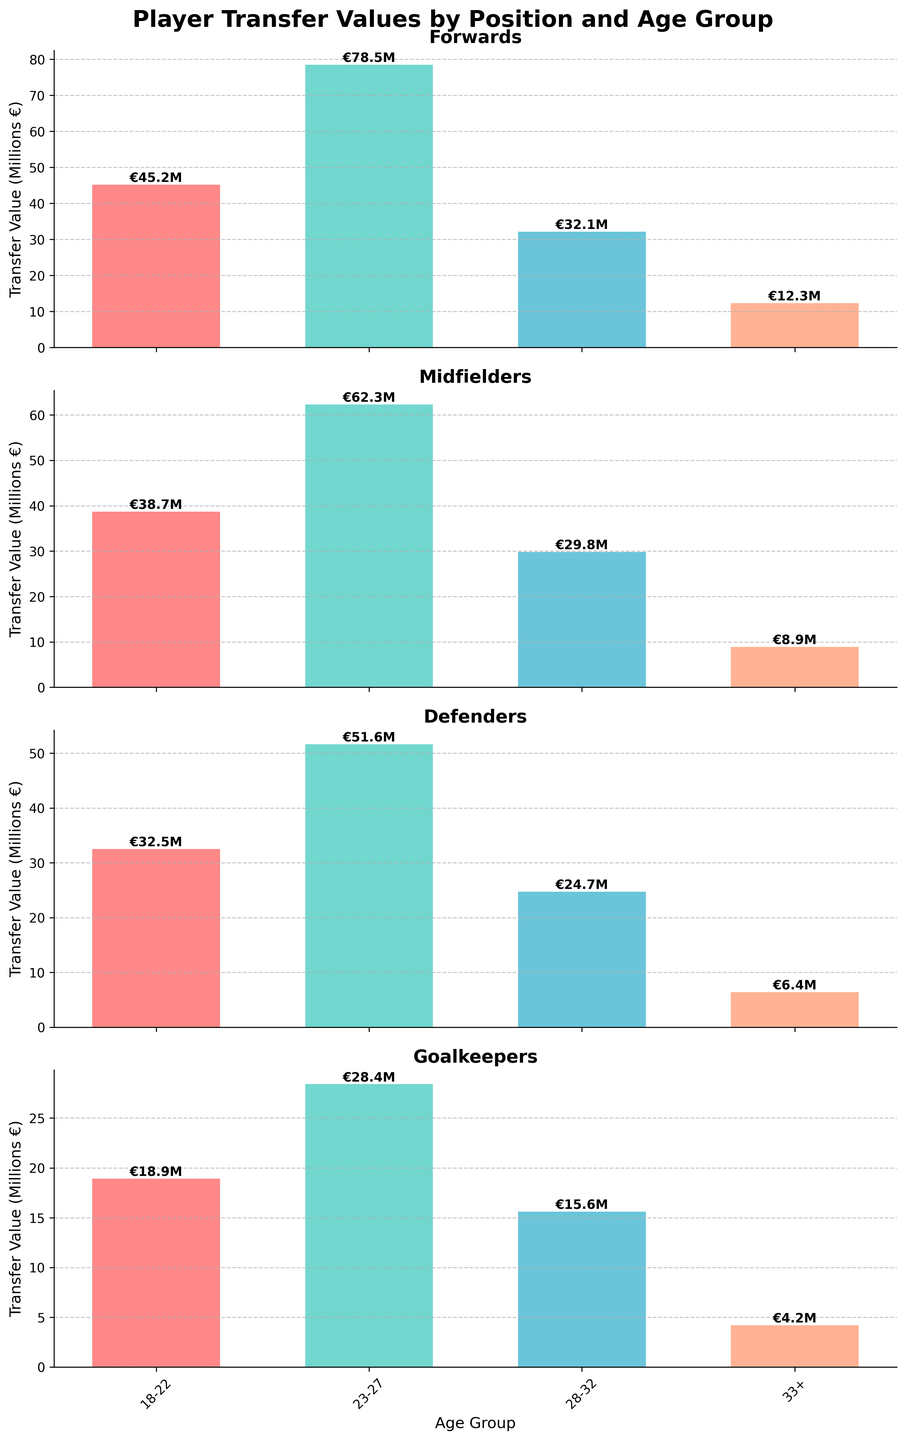What is the highest transfer value for forwards? Looking at the subplot for forwards, the highest bar represents the age group of 23-27 years with a transfer value of €78.5 million.
Answer: €78.5 million How do the transfer values of defenders age 33+ compare to that of goalkeepers age 33+? The subplot for defenders shows a transfer value of €6.4 million for the 33+ age group, while the goalkeepers subplot shows a transfer value of €4.2 million for the same age group. Comparing these values, defenders have a higher transfer value than goalkeepers in the 33+ age group.
Answer: Defenders' value is higher What is the average transfer value for midfielders across all age groups? The transfer values for midfielders across age groups are €38.7 million, €62.3 million, €29.8 million, and €8.9 million. Adding these values gives a total of €139.7 million, and dividing by 4 (the number of age groups) gives an average of approximately €34.93 million.
Answer: €34.93 million Which age group of goalkeepers has the lowest transfer value? The subplot for goalkeepers shows the transfer values for different age groups. The 33+ age group has the lowest transfer value at €4.2 million.
Answer: 33+ What is the difference in transfer value between forwards age 23-27 and midfielders age 23-27? The transfer value for forwards age 23-27 is €78.5 million and for midfielders age 23-27 is €62.3 million. Subtracting the two, the difference is €78.5 million - €62.3 million = €16.2 million.
Answer: €16.2 million Which position has the highest transfer value for the 18-22 age group? Among the subplots, comparing the transfer values for the 18-22 age group, forwards have the highest transfer value at €45.2 million.
Answer: Forwards Which position and age group has the transfer value closest to €30 million? Looking at the subplots, the transfer value closest to €30 million is for midfielders age 28-32 with a value of €29.8 million.
Answer: Midfielders age 28-32 How does the average transfer value of goalkeepers compare to the average transfer value of defenders? The transfer values for goalkeepers are €18.9 million, €28.4 million, €15.6 million, and €4.2 million. Their average is (€18.9 + €28.4 + €15.6 + €4.2) / 4 = €67.1 / 4 = €16.775 million. For defenders, the values are €32.5 million, €51.6 million, €24.7 million, and €6.4 million. Their average is (€32.5 + €51.6 + €24.7 + €6.4) / 4 = €115.2 / 4 = €28.8 million. Comparing these averages, defenders have a higher average transfer value than goalkeepers.
Answer: Defenders' average is higher 